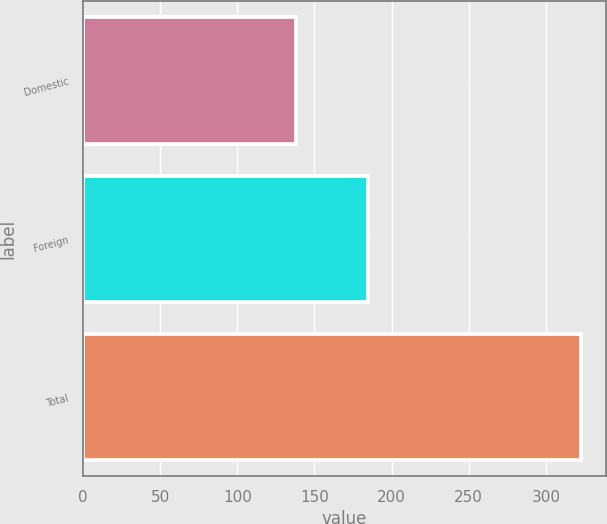Convert chart. <chart><loc_0><loc_0><loc_500><loc_500><bar_chart><fcel>Domestic<fcel>Foreign<fcel>Total<nl><fcel>138.1<fcel>184.8<fcel>322.9<nl></chart> 